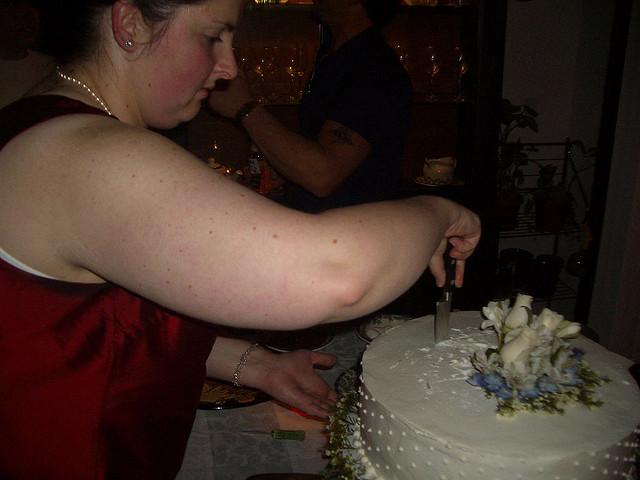What utensil is the woman using?
Be succinct. Knife. What is the lady doing?
Quick response, please. Cutting cake. What gender is here?
Answer briefly. Female. Is this at a party?
Be succinct. Yes. What is being served in the bowl?
Keep it brief. Cake. What is the woman cutting?
Answer briefly. Cake. 